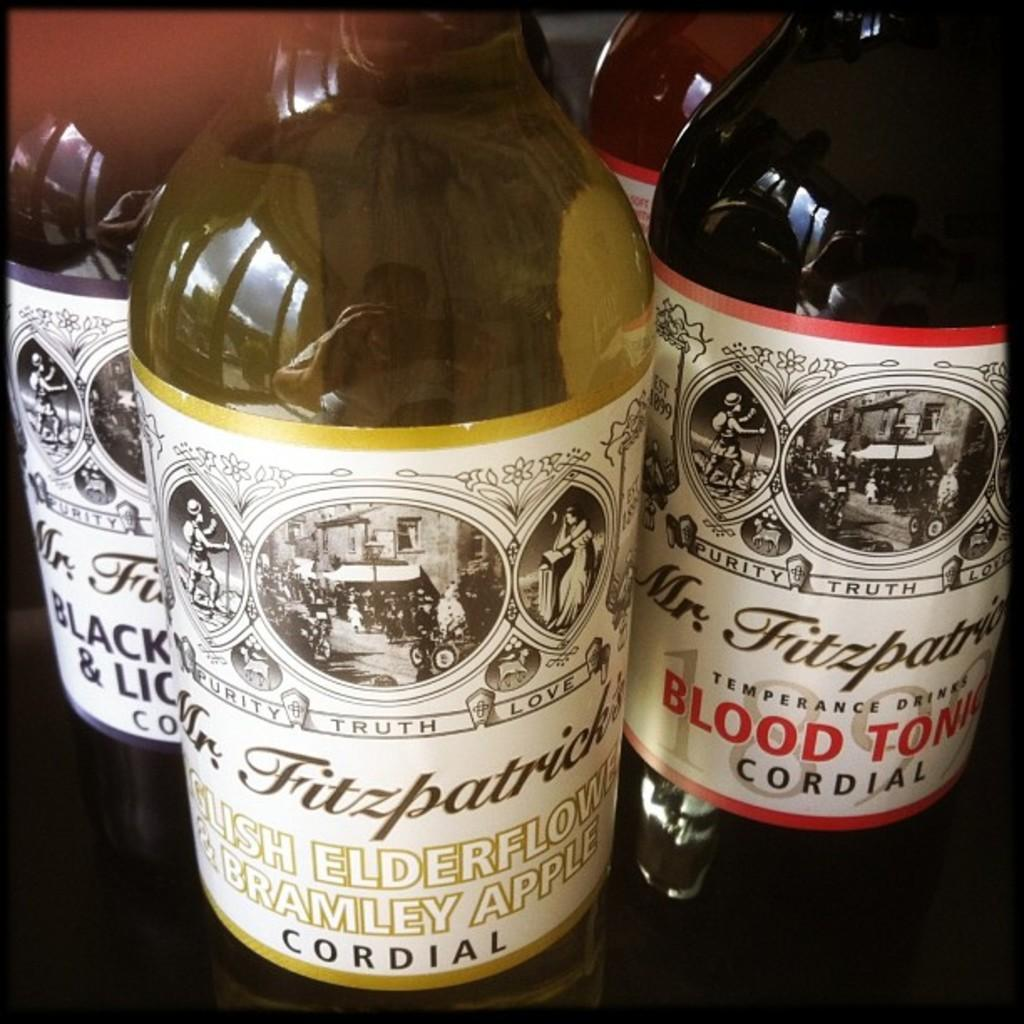<image>
Write a terse but informative summary of the picture. Three bottles of Mr. Fitzpatrick cordial purity drinks. 